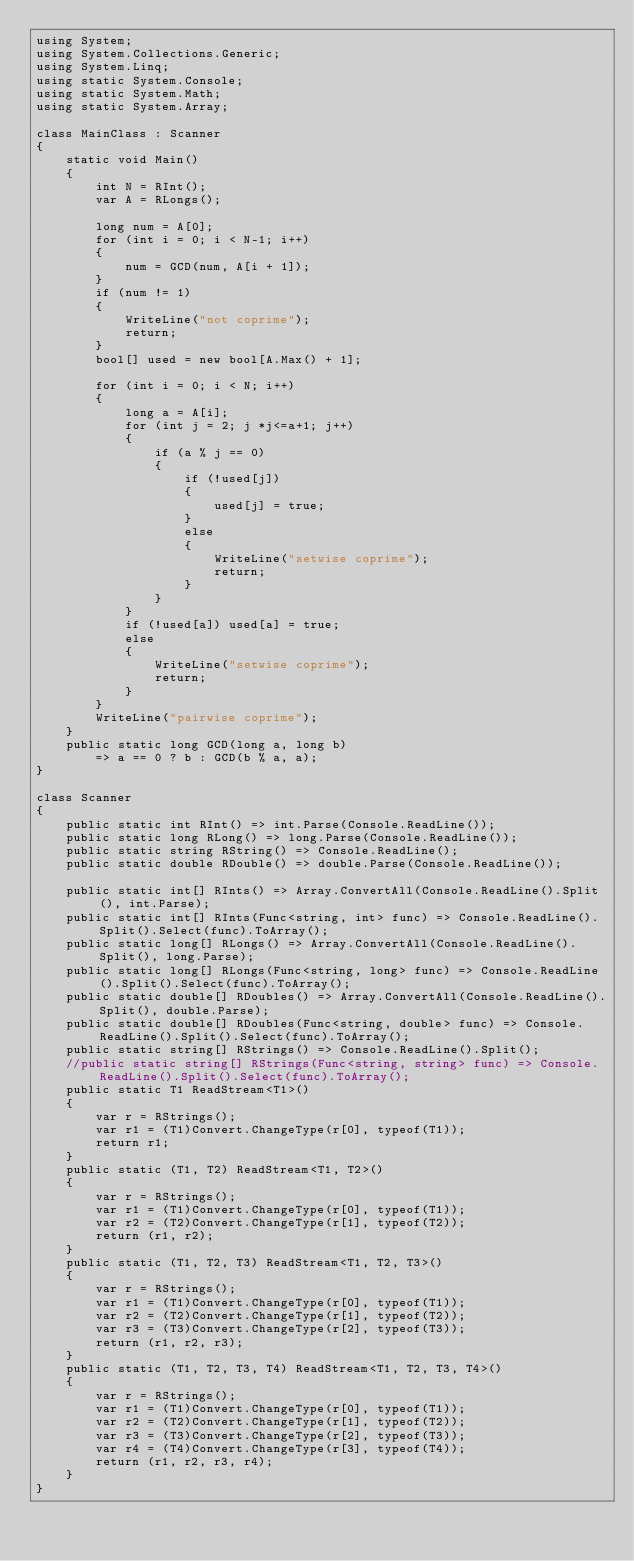<code> <loc_0><loc_0><loc_500><loc_500><_C#_>using System;
using System.Collections.Generic;
using System.Linq;
using static System.Console;
using static System.Math;
using static System.Array;

class MainClass : Scanner
{
    static void Main()
    {
        int N = RInt();
        var A = RLongs();
        
        long num = A[0];
        for (int i = 0; i < N-1; i++)
        {
            num = GCD(num, A[i + 1]);
        }
        if (num != 1)
        {
            WriteLine("not coprime");
            return;
        }
        bool[] used = new bool[A.Max() + 1];

        for (int i = 0; i < N; i++)
        {
            long a = A[i];
            for (int j = 2; j *j<=a+1; j++)
            {
                if (a % j == 0)
                {
                    if (!used[j])
                    {
                        used[j] = true;
                    }
                    else
                    {
                        WriteLine("setwise coprime");
                        return;
                    }
                }
            }
            if (!used[a]) used[a] = true;
            else
            {
                WriteLine("setwise coprime");
                return;
            }
        }
        WriteLine("pairwise coprime");
    }
    public static long GCD(long a, long b)
        => a == 0 ? b : GCD(b % a, a);
}

class Scanner
{
    public static int RInt() => int.Parse(Console.ReadLine());
    public static long RLong() => long.Parse(Console.ReadLine());
    public static string RString() => Console.ReadLine();
    public static double RDouble() => double.Parse(Console.ReadLine());

    public static int[] RInts() => Array.ConvertAll(Console.ReadLine().Split(), int.Parse);
    public static int[] RInts(Func<string, int> func) => Console.ReadLine().Split().Select(func).ToArray();
    public static long[] RLongs() => Array.ConvertAll(Console.ReadLine().Split(), long.Parse);
    public static long[] RLongs(Func<string, long> func) => Console.ReadLine().Split().Select(func).ToArray();
    public static double[] RDoubles() => Array.ConvertAll(Console.ReadLine().Split(), double.Parse);
    public static double[] RDoubles(Func<string, double> func) => Console.ReadLine().Split().Select(func).ToArray();
    public static string[] RStrings() => Console.ReadLine().Split();
    //public static string[] RStrings(Func<string, string> func) => Console.ReadLine().Split().Select(func).ToArray();
    public static T1 ReadStream<T1>()
    {
        var r = RStrings();
        var r1 = (T1)Convert.ChangeType(r[0], typeof(T1));
        return r1;
    }
    public static (T1, T2) ReadStream<T1, T2>()
    {
        var r = RStrings();
        var r1 = (T1)Convert.ChangeType(r[0], typeof(T1));
        var r2 = (T2)Convert.ChangeType(r[1], typeof(T2));
        return (r1, r2);
    }
    public static (T1, T2, T3) ReadStream<T1, T2, T3>()
    {
        var r = RStrings();
        var r1 = (T1)Convert.ChangeType(r[0], typeof(T1));
        var r2 = (T2)Convert.ChangeType(r[1], typeof(T2));
        var r3 = (T3)Convert.ChangeType(r[2], typeof(T3));
        return (r1, r2, r3);
    }
    public static (T1, T2, T3, T4) ReadStream<T1, T2, T3, T4>()
    {
        var r = RStrings();
        var r1 = (T1)Convert.ChangeType(r[0], typeof(T1));
        var r2 = (T2)Convert.ChangeType(r[1], typeof(T2));
        var r3 = (T3)Convert.ChangeType(r[2], typeof(T3));
        var r4 = (T4)Convert.ChangeType(r[3], typeof(T4));
        return (r1, r2, r3, r4);
    }
}</code> 